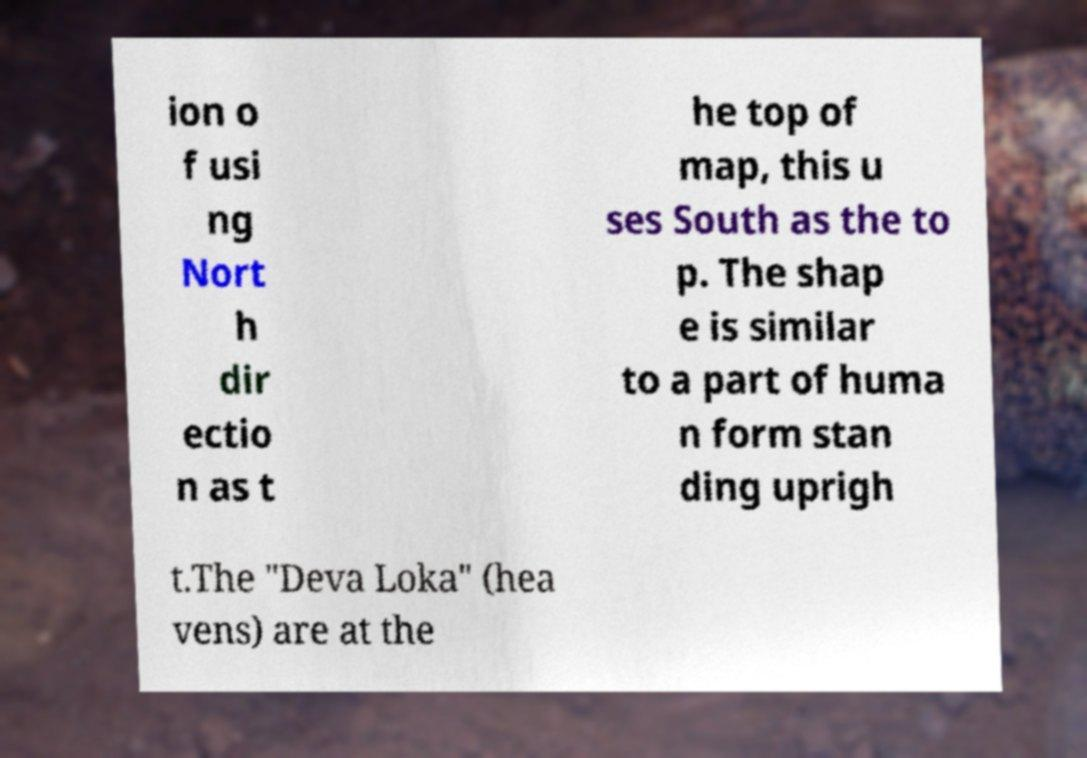For documentation purposes, I need the text within this image transcribed. Could you provide that? ion o f usi ng Nort h dir ectio n as t he top of map, this u ses South as the to p. The shap e is similar to a part of huma n form stan ding uprigh t.The "Deva Loka" (hea vens) are at the 